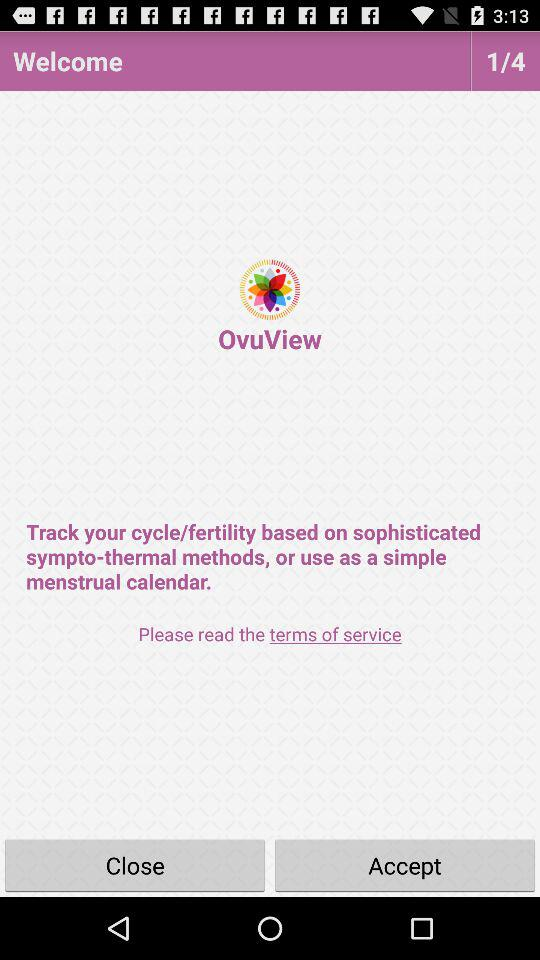Which page are we currently on? You are currently on page 1. 